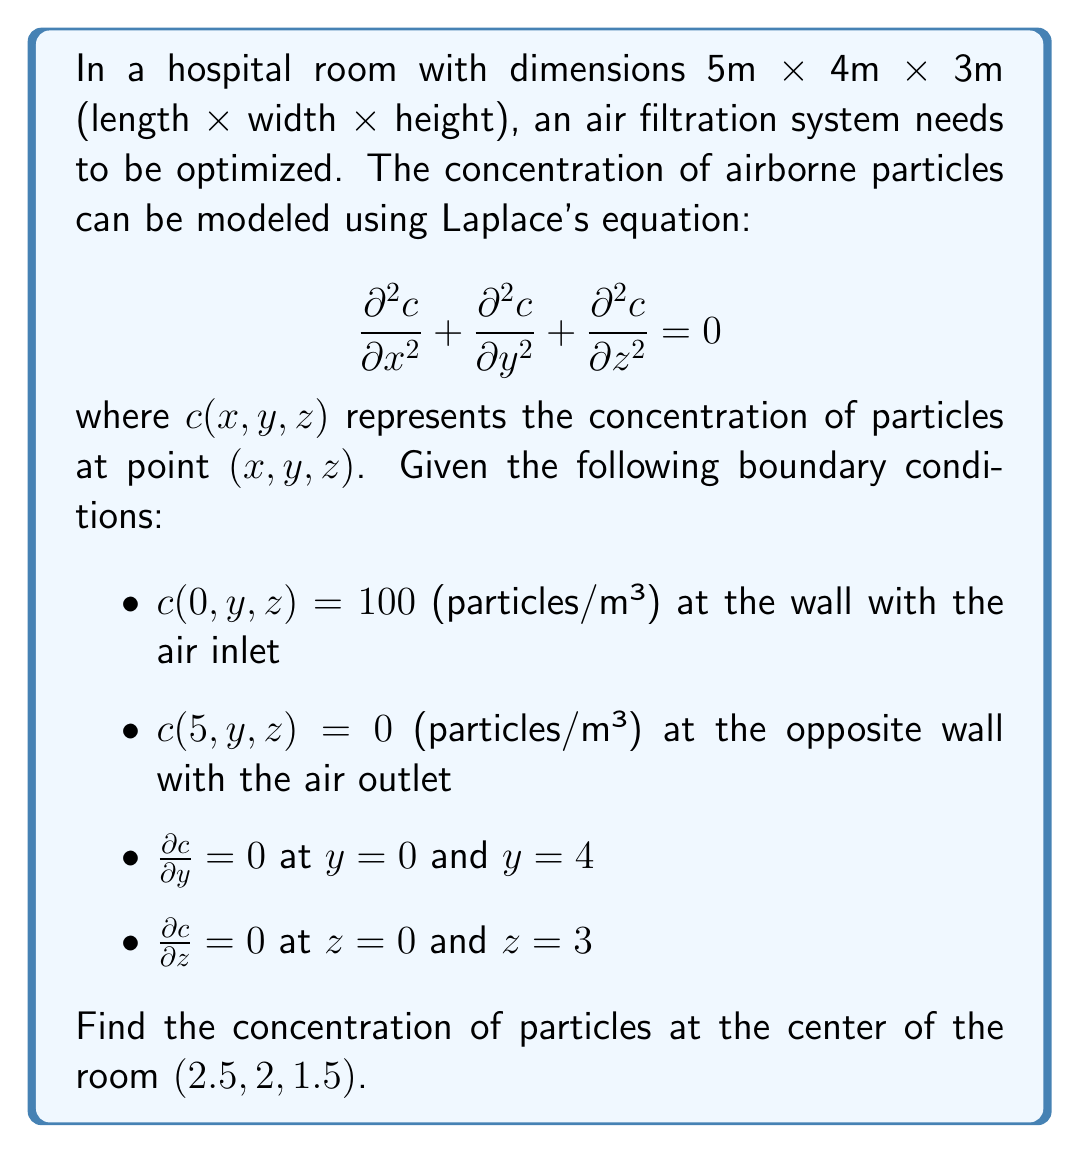Teach me how to tackle this problem. To solve this problem, we need to use the method of separation of variables for Laplace's equation in three dimensions.

1) Assume the solution has the form: $c(x,y,z) = X(x)Y(y)Z(z)$

2) Substituting this into Laplace's equation:

   $$\frac{1}{X}\frac{d^2X}{dx^2} + \frac{1}{Y}\frac{d^2Y}{dy^2} + \frac{1}{Z}\frac{d^2Z}{dz^2} = 0$$

3) Each term must be constant. Let's say:

   $$\frac{1}{X}\frac{d^2X}{dx^2} = -k^2, \frac{1}{Y}\frac{d^2Y}{dy^2} = -m^2, \frac{1}{Z}\frac{d^2Z}{dz^2} = -n^2$$

   where $k^2 + m^2 + n^2 = 0$

4) The general solutions are:

   $X(x) = A\sin(kx) + B\cos(kx)$
   $Y(y) = C\sin(my) + D\cos(my)$
   $Z(z) = E\sin(nz) + F\cos(nz)$

5) Applying the boundary conditions:

   For $X(x)$: $X(0) = 100$ and $X(5) = 0$
   This gives: $X(x) = 100\sin(\frac{\pi x}{5})$

   For $Y(y)$ and $Z(z)$, the zero derivative conditions at both ends result in:
   $Y(y) = 1$ and $Z(z) = 1$

6) Therefore, the solution is:

   $$c(x,y,z) = 100\sin(\frac{\pi x}{5})$$

7) To find the concentration at $(2.5, 2, 1.5)$, we simply substitute $x = 2.5$:

   $$c(2.5, 2, 1.5) = 100\sin(\frac{\pi 2.5}{5}) = 100\sin(\frac{\pi}{2}) = 100$$
Answer: The concentration of particles at the center of the room $(2.5, 2, 1.5)$ is 100 particles/m³. 